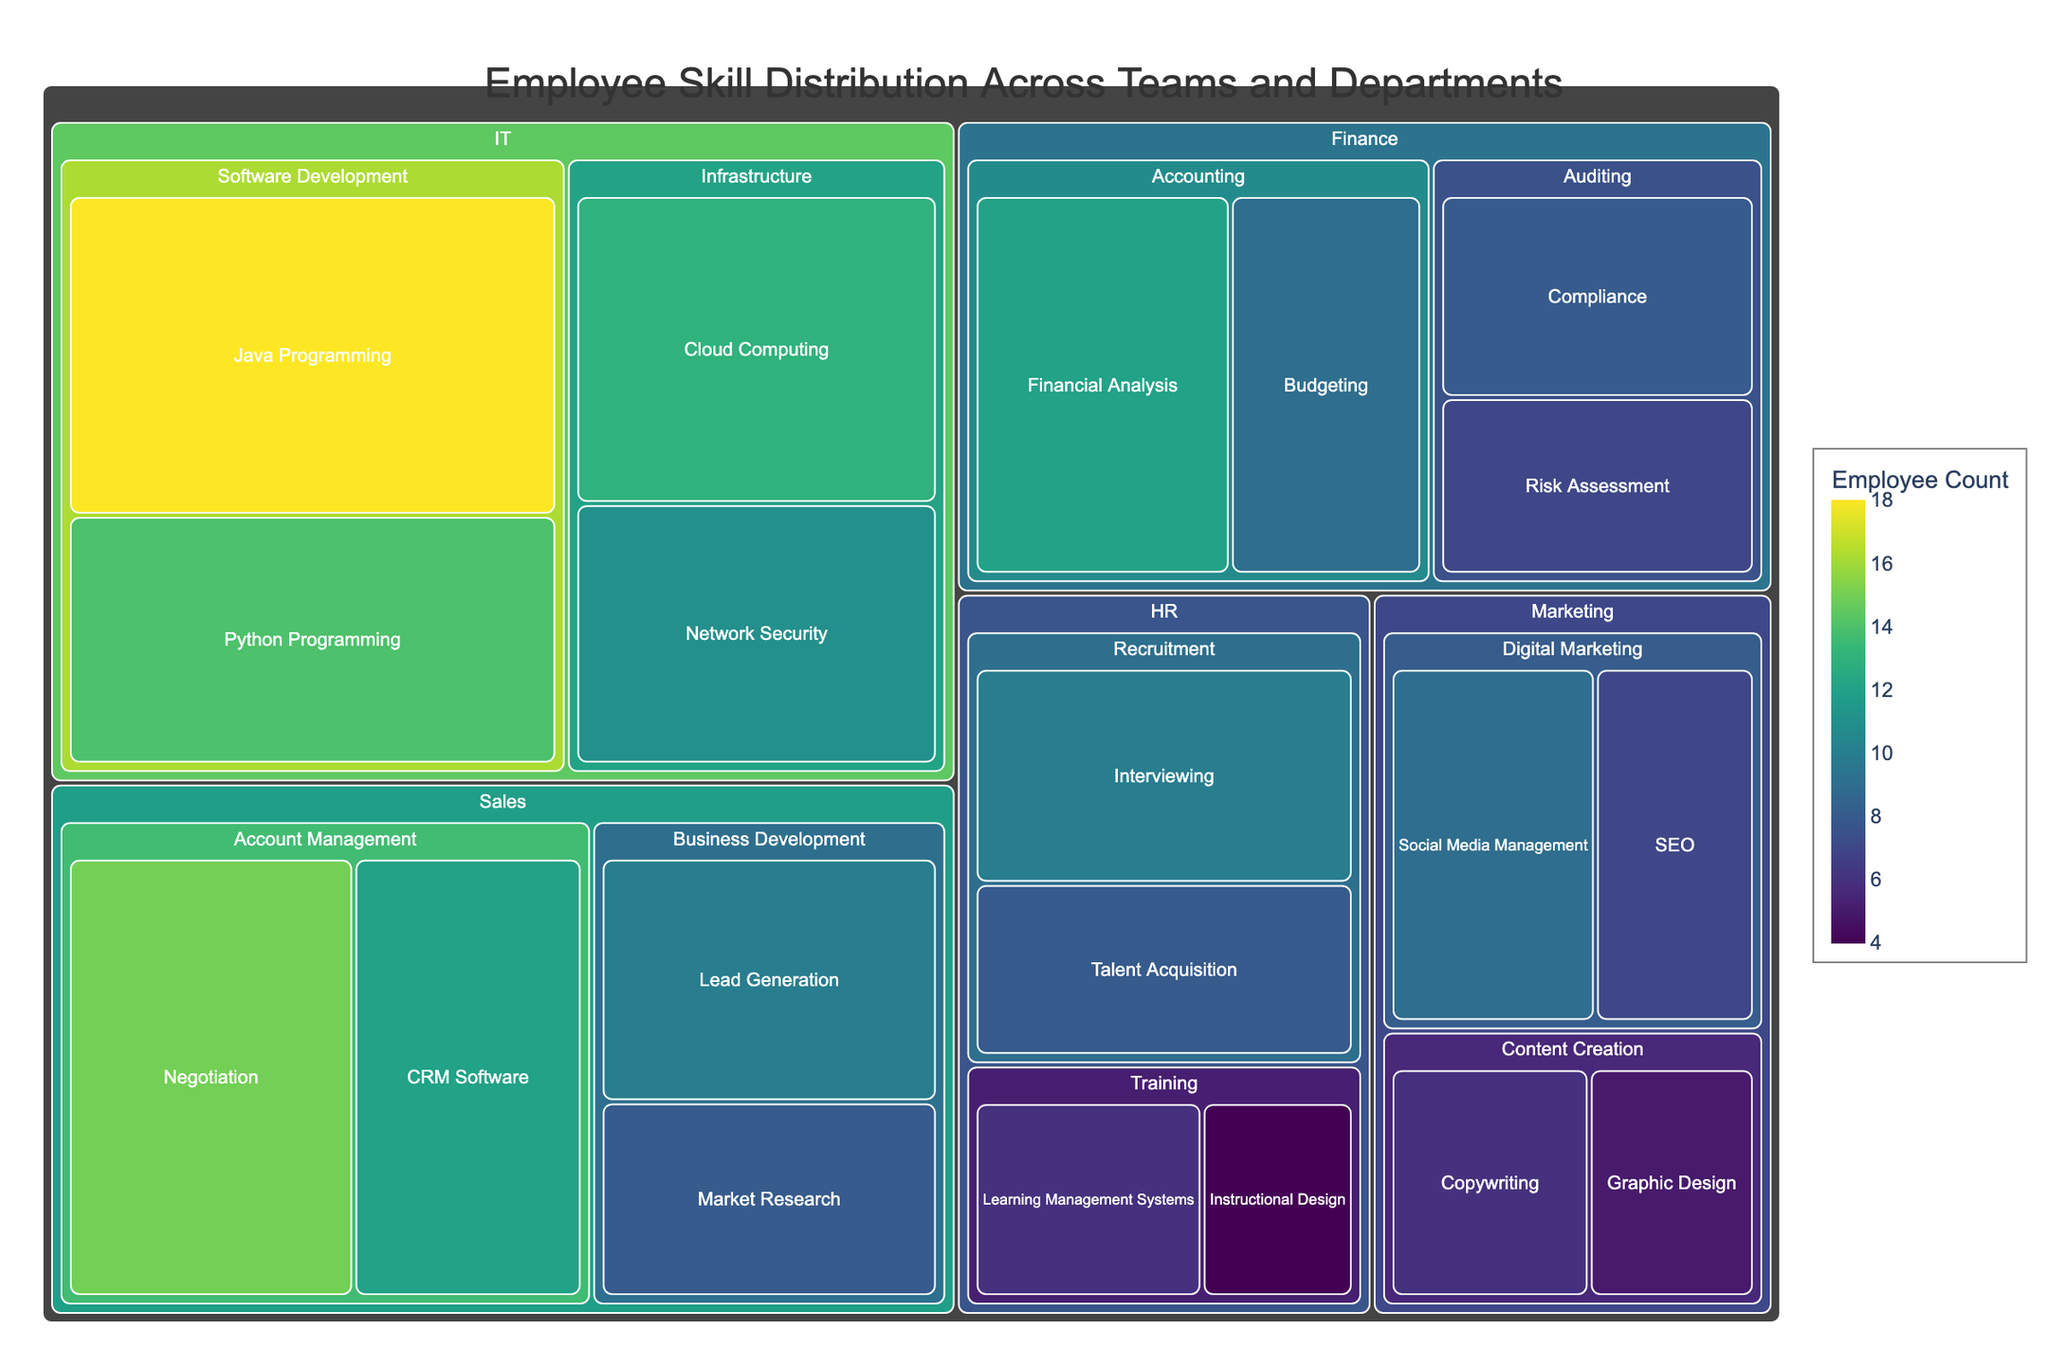What's the title of the figure? The title is typically displayed at the top of the figure. Here, it reads 'Employee Skill Distribution Across Teams and Departments'.
Answer: Employee Skill Distribution Across Teams and Departments Which Department has the highest Employee Count in total? To determine this, we need to look at the color intensity and aggregate counts for each Department. The IT department has the most intense color patches suggesting a higher total Employee Count.
Answer: IT How many employees are proficient in Java Programming? By visiting the Software Development team under the IT department, the count for Java Programming is displayed as 18.
Answer: 18 Which Team in the Sales Department has more employees skilled in Lead Generation or Market Research? Examine the boxes for Lead Generation and Market Research under Business Development in Sales. Lead Generation has a count of 10, whereas Market Research has 8.
Answer: Lead Generation What is the combined Employee Count for skills under the Digital Marketing team in the Marketing Department? Add the counts for SEO and Social Media Management under Digital Marketing in Marketing. SEO has 7 and Social Media Management has 9. Summing them up gives 16.
Answer: 16 Which Department has the fewest employees, and what is the count of their largest skill? Each department can be compared by the combined size of their areas. The HR department appears smallest, with Talent Acquisition having the highest count within it of 8.
Answer: HR, Talent Acquisition with 8 Compare the Employee Count of Financial Analysis in Finance with Java Programming in IT. Which has more employees? Financial Analysis has a count of 12, while Java Programming has 18. Java Programming in IT has more employees.
Answer: Java Programming in IT What percentage of IT employees are into Python Programming? Calculate by comparing Python Programming's count (14) against the total IT count (sum of all counts under IT). The total IT count is 56. So the percentage is (14/56) * 100 ≈ 25%.
Answer: 25% In the HR Training team, which skill has more employees? The skills under Training in HR are Learning Management Systems with 6 and Instructional Design with 4. Learning Management Systems has more employees.
Answer: Learning Management Systems Which department has the most diverse skill set? Compare the number of unique skills listed under each department. IT, with skills such as Java Programming, Python Programming, Network Security, and Cloud Computing, seems to have the widest variety.
Answer: IT 